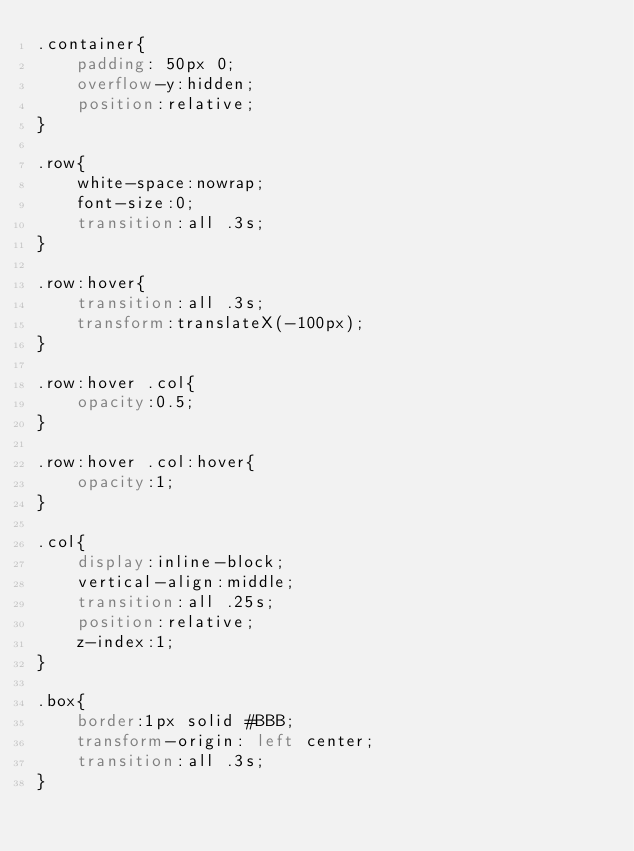<code> <loc_0><loc_0><loc_500><loc_500><_CSS_>.container{
    padding: 50px 0;
    overflow-y:hidden;
    position:relative;
}

.row{
    white-space:nowrap;
    font-size:0;
    transition:all .3s;
}

.row:hover{
    transition:all .3s;
    transform:translateX(-100px);
}

.row:hover .col{
    opacity:0.5;
}

.row:hover .col:hover{
    opacity:1;
}

.col{
    display:inline-block;
    vertical-align:middle;
    transition:all .25s;  
    position:relative;
    z-index:1;
}

.box{
    border:1px solid #BBB;
    transform-origin: left center;
    transition:all .3s; 
}
</code> 